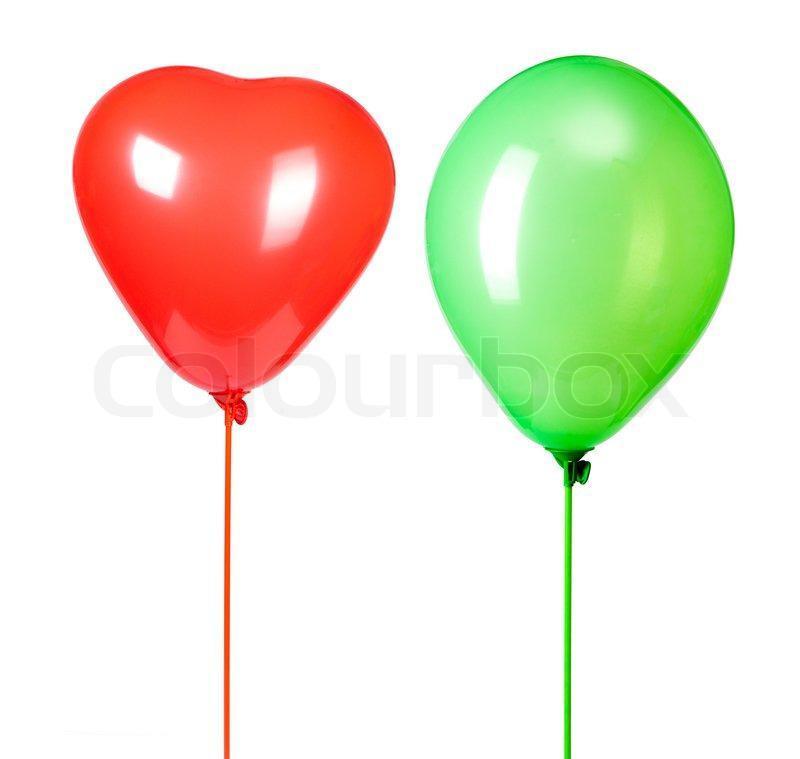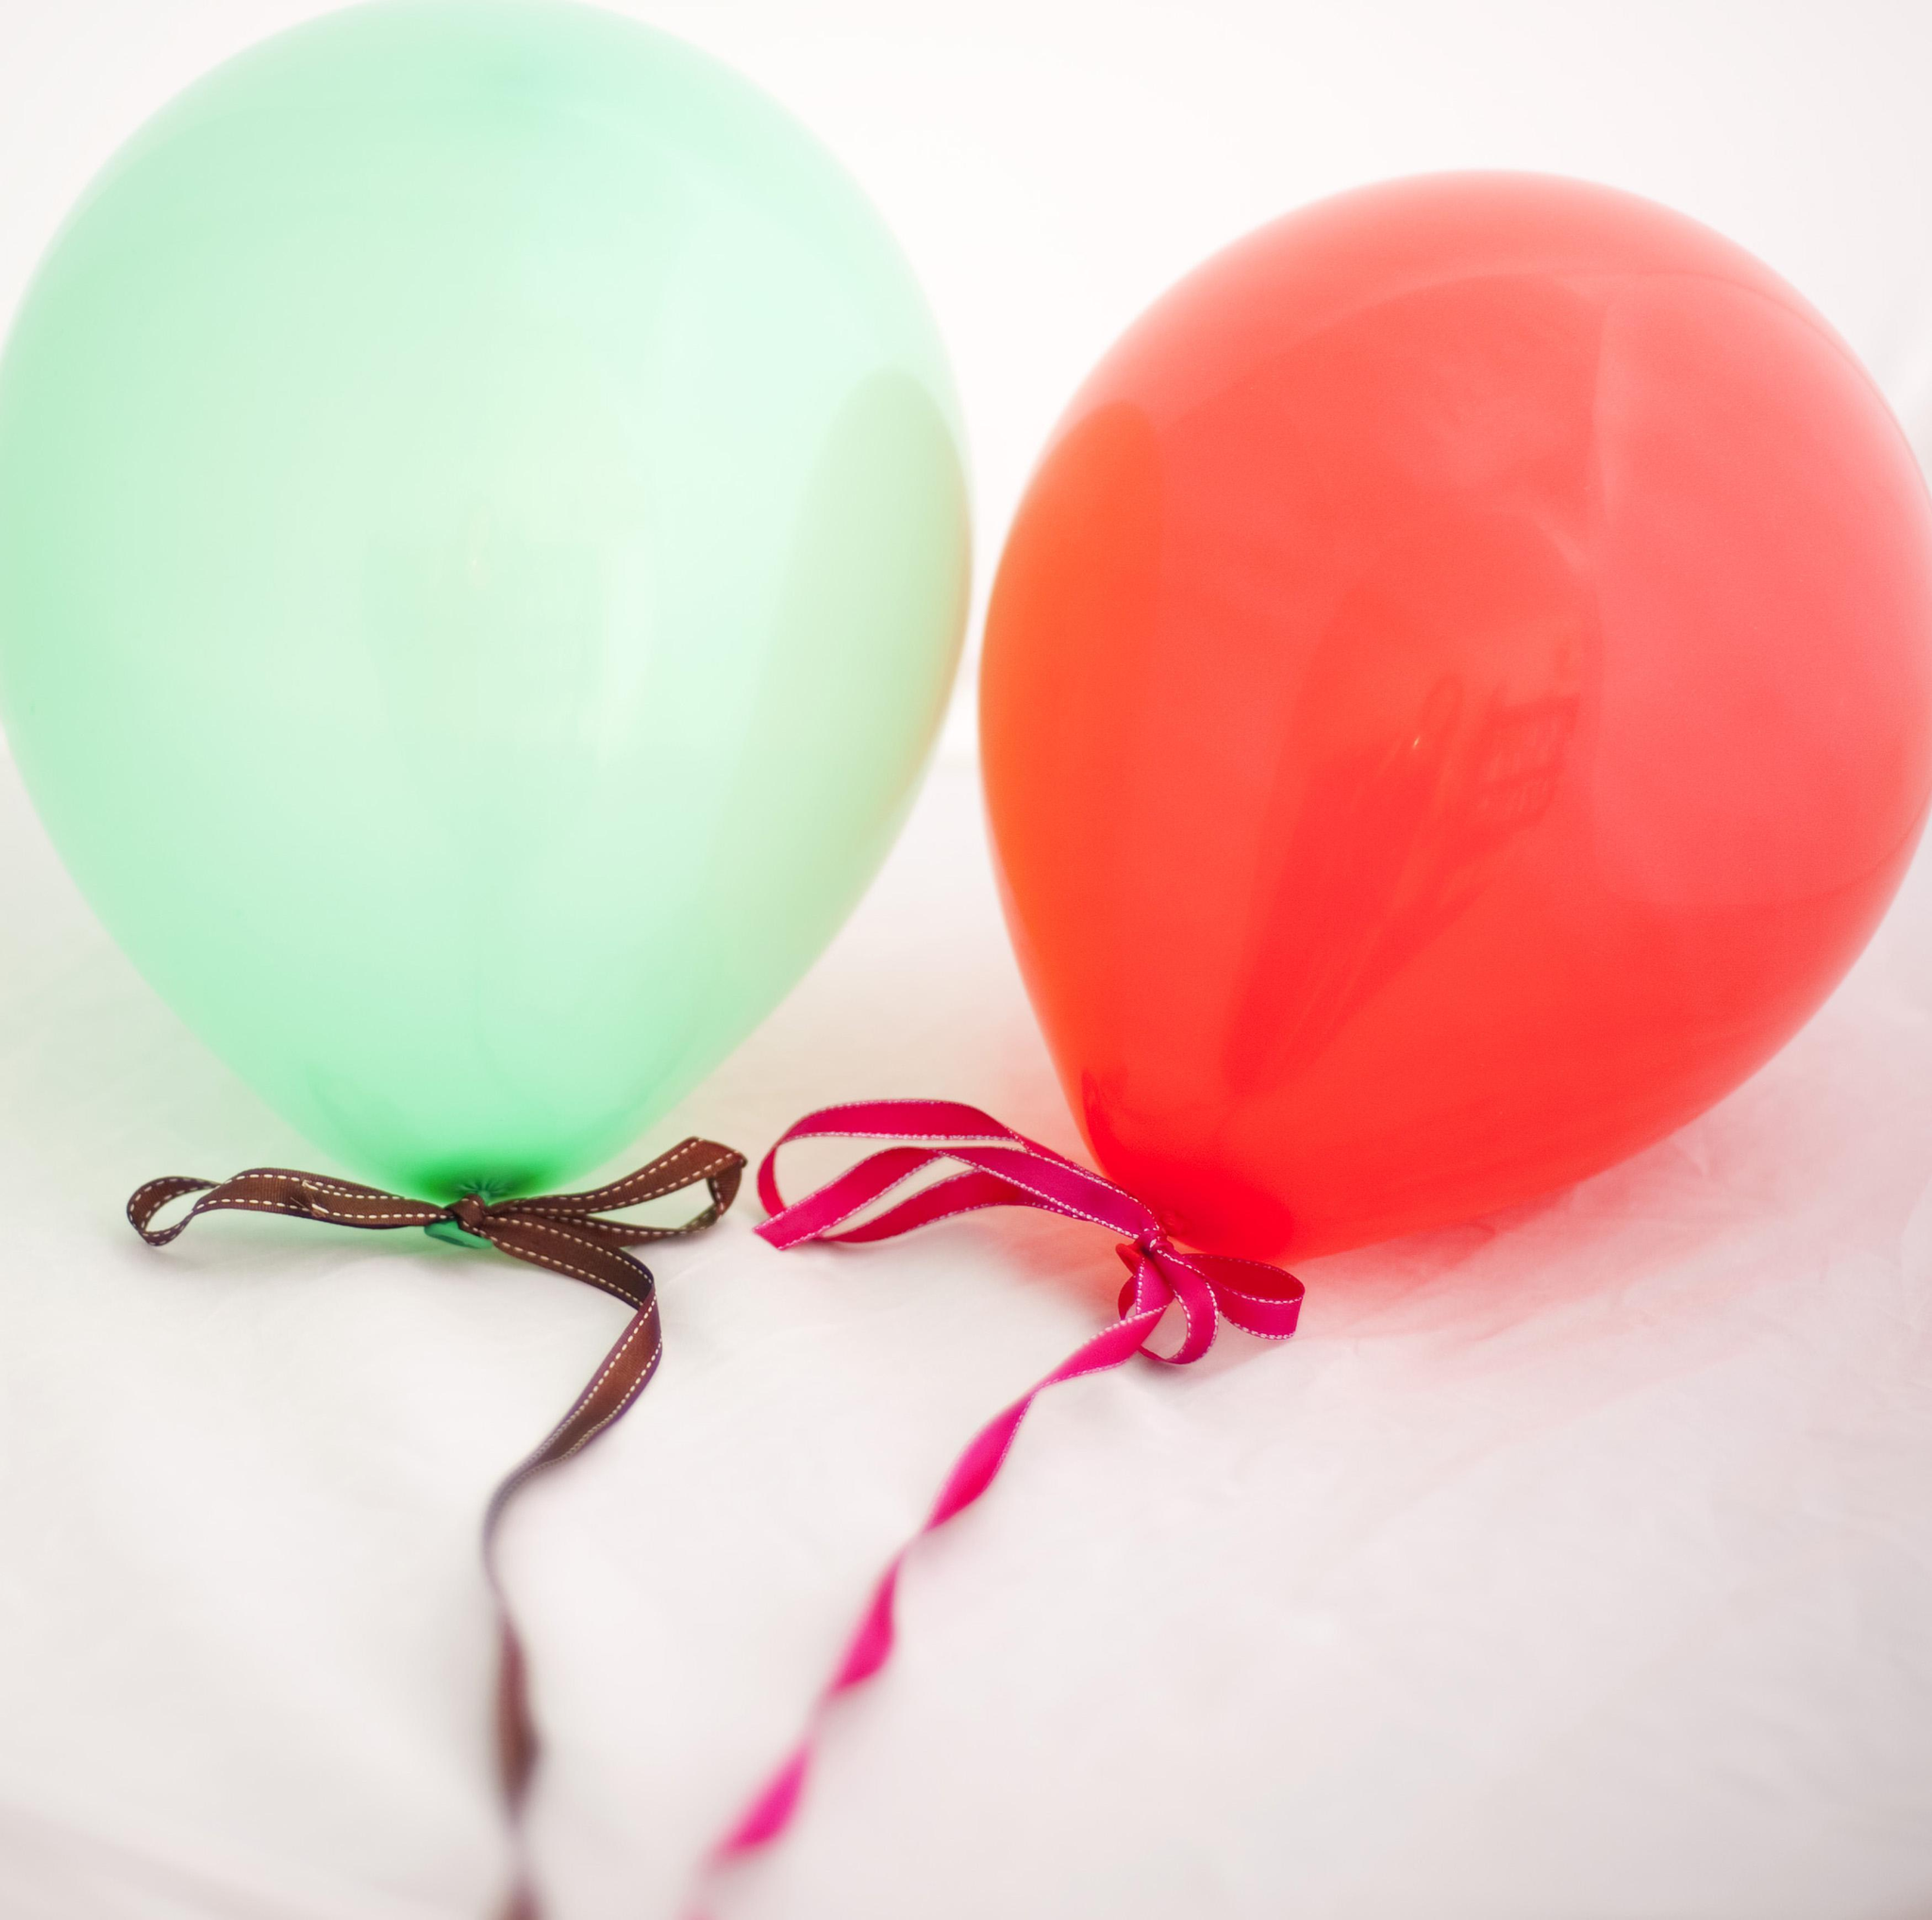The first image is the image on the left, the second image is the image on the right. For the images shown, is this caption "There are two red balloons and two green balloons" true? Answer yes or no. Yes. The first image is the image on the left, the second image is the image on the right. Analyze the images presented: Is the assertion "There is a heart shaped balloon" valid? Answer yes or no. Yes. 